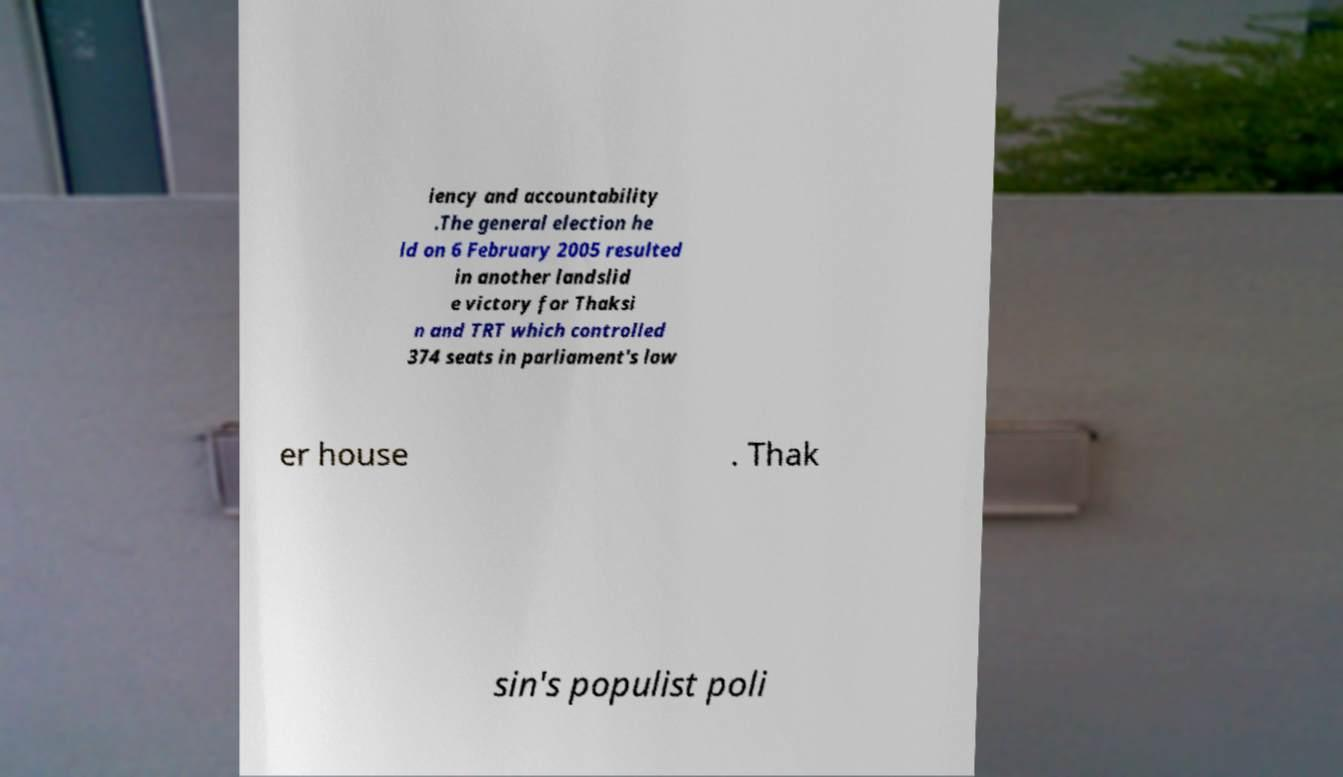Can you read and provide the text displayed in the image?This photo seems to have some interesting text. Can you extract and type it out for me? iency and accountability .The general election he ld on 6 February 2005 resulted in another landslid e victory for Thaksi n and TRT which controlled 374 seats in parliament's low er house . Thak sin's populist poli 